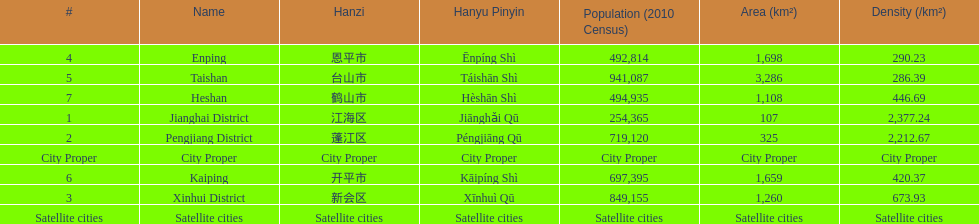What is the most populated district? Taishan. 